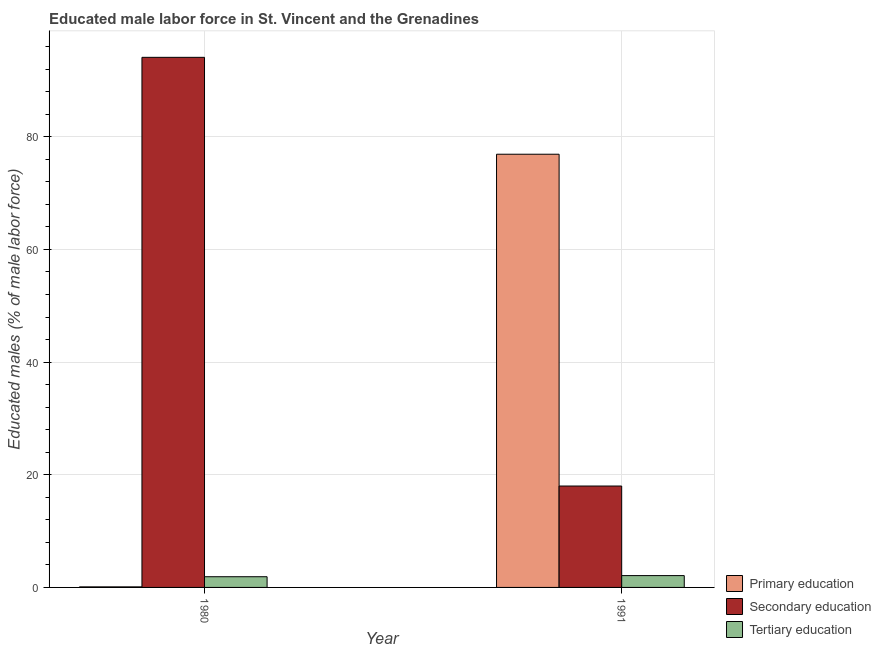How many different coloured bars are there?
Provide a succinct answer. 3. How many bars are there on the 2nd tick from the left?
Provide a short and direct response. 3. What is the label of the 1st group of bars from the left?
Offer a very short reply. 1980. In how many cases, is the number of bars for a given year not equal to the number of legend labels?
Your answer should be compact. 0. What is the percentage of male labor force who received primary education in 1980?
Your answer should be compact. 0.1. Across all years, what is the maximum percentage of male labor force who received primary education?
Provide a short and direct response. 76.9. Across all years, what is the minimum percentage of male labor force who received primary education?
Your answer should be very brief. 0.1. In which year was the percentage of male labor force who received primary education maximum?
Your answer should be compact. 1991. In which year was the percentage of male labor force who received tertiary education minimum?
Ensure brevity in your answer.  1980. What is the total percentage of male labor force who received tertiary education in the graph?
Offer a very short reply. 4. What is the difference between the percentage of male labor force who received tertiary education in 1980 and that in 1991?
Make the answer very short. -0.2. What is the difference between the percentage of male labor force who received primary education in 1980 and the percentage of male labor force who received secondary education in 1991?
Your response must be concise. -76.8. What is the average percentage of male labor force who received secondary education per year?
Provide a succinct answer. 56.05. In how many years, is the percentage of male labor force who received primary education greater than 8 %?
Provide a succinct answer. 1. What is the ratio of the percentage of male labor force who received secondary education in 1980 to that in 1991?
Your answer should be compact. 5.23. What does the 3rd bar from the left in 1980 represents?
Provide a succinct answer. Tertiary education. What does the 1st bar from the right in 1980 represents?
Your response must be concise. Tertiary education. How many bars are there?
Provide a succinct answer. 6. How many years are there in the graph?
Your answer should be compact. 2. What is the difference between two consecutive major ticks on the Y-axis?
Make the answer very short. 20. Are the values on the major ticks of Y-axis written in scientific E-notation?
Your answer should be very brief. No. Does the graph contain grids?
Keep it short and to the point. Yes. What is the title of the graph?
Keep it short and to the point. Educated male labor force in St. Vincent and the Grenadines. What is the label or title of the X-axis?
Offer a very short reply. Year. What is the label or title of the Y-axis?
Provide a succinct answer. Educated males (% of male labor force). What is the Educated males (% of male labor force) in Primary education in 1980?
Offer a very short reply. 0.1. What is the Educated males (% of male labor force) in Secondary education in 1980?
Offer a very short reply. 94.1. What is the Educated males (% of male labor force) of Tertiary education in 1980?
Offer a terse response. 1.9. What is the Educated males (% of male labor force) in Primary education in 1991?
Your answer should be very brief. 76.9. What is the Educated males (% of male labor force) in Tertiary education in 1991?
Offer a very short reply. 2.1. Across all years, what is the maximum Educated males (% of male labor force) of Primary education?
Your response must be concise. 76.9. Across all years, what is the maximum Educated males (% of male labor force) in Secondary education?
Your response must be concise. 94.1. Across all years, what is the maximum Educated males (% of male labor force) of Tertiary education?
Give a very brief answer. 2.1. Across all years, what is the minimum Educated males (% of male labor force) of Primary education?
Your response must be concise. 0.1. Across all years, what is the minimum Educated males (% of male labor force) in Secondary education?
Make the answer very short. 18. Across all years, what is the minimum Educated males (% of male labor force) of Tertiary education?
Provide a succinct answer. 1.9. What is the total Educated males (% of male labor force) of Secondary education in the graph?
Give a very brief answer. 112.1. What is the total Educated males (% of male labor force) of Tertiary education in the graph?
Offer a very short reply. 4. What is the difference between the Educated males (% of male labor force) of Primary education in 1980 and that in 1991?
Your answer should be compact. -76.8. What is the difference between the Educated males (% of male labor force) of Secondary education in 1980 and that in 1991?
Ensure brevity in your answer.  76.1. What is the difference between the Educated males (% of male labor force) of Primary education in 1980 and the Educated males (% of male labor force) of Secondary education in 1991?
Your response must be concise. -17.9. What is the difference between the Educated males (% of male labor force) in Secondary education in 1980 and the Educated males (% of male labor force) in Tertiary education in 1991?
Offer a terse response. 92. What is the average Educated males (% of male labor force) of Primary education per year?
Make the answer very short. 38.5. What is the average Educated males (% of male labor force) in Secondary education per year?
Your answer should be very brief. 56.05. What is the average Educated males (% of male labor force) in Tertiary education per year?
Your response must be concise. 2. In the year 1980, what is the difference between the Educated males (% of male labor force) of Primary education and Educated males (% of male labor force) of Secondary education?
Your response must be concise. -94. In the year 1980, what is the difference between the Educated males (% of male labor force) in Primary education and Educated males (% of male labor force) in Tertiary education?
Offer a very short reply. -1.8. In the year 1980, what is the difference between the Educated males (% of male labor force) in Secondary education and Educated males (% of male labor force) in Tertiary education?
Ensure brevity in your answer.  92.2. In the year 1991, what is the difference between the Educated males (% of male labor force) in Primary education and Educated males (% of male labor force) in Secondary education?
Your answer should be very brief. 58.9. In the year 1991, what is the difference between the Educated males (% of male labor force) of Primary education and Educated males (% of male labor force) of Tertiary education?
Your answer should be very brief. 74.8. What is the ratio of the Educated males (% of male labor force) of Primary education in 1980 to that in 1991?
Provide a succinct answer. 0. What is the ratio of the Educated males (% of male labor force) of Secondary education in 1980 to that in 1991?
Offer a very short reply. 5.23. What is the ratio of the Educated males (% of male labor force) in Tertiary education in 1980 to that in 1991?
Give a very brief answer. 0.9. What is the difference between the highest and the second highest Educated males (% of male labor force) in Primary education?
Give a very brief answer. 76.8. What is the difference between the highest and the second highest Educated males (% of male labor force) of Secondary education?
Your answer should be very brief. 76.1. What is the difference between the highest and the lowest Educated males (% of male labor force) in Primary education?
Make the answer very short. 76.8. What is the difference between the highest and the lowest Educated males (% of male labor force) in Secondary education?
Your response must be concise. 76.1. 